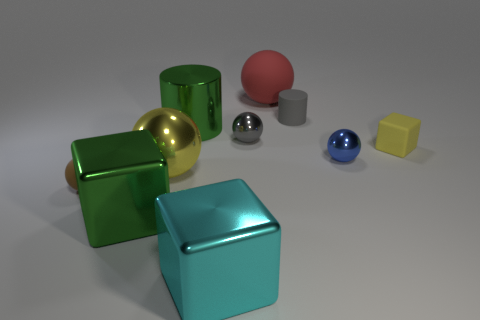There is a cube that is made of the same material as the red sphere; what size is it? The cube that shares the same material properties as the red sphere appears to be medium-sized compared to the other objects in the image. It showcases a reflective surface indicating a similar composition, possibly a glossy paint or a plastic-like material. 